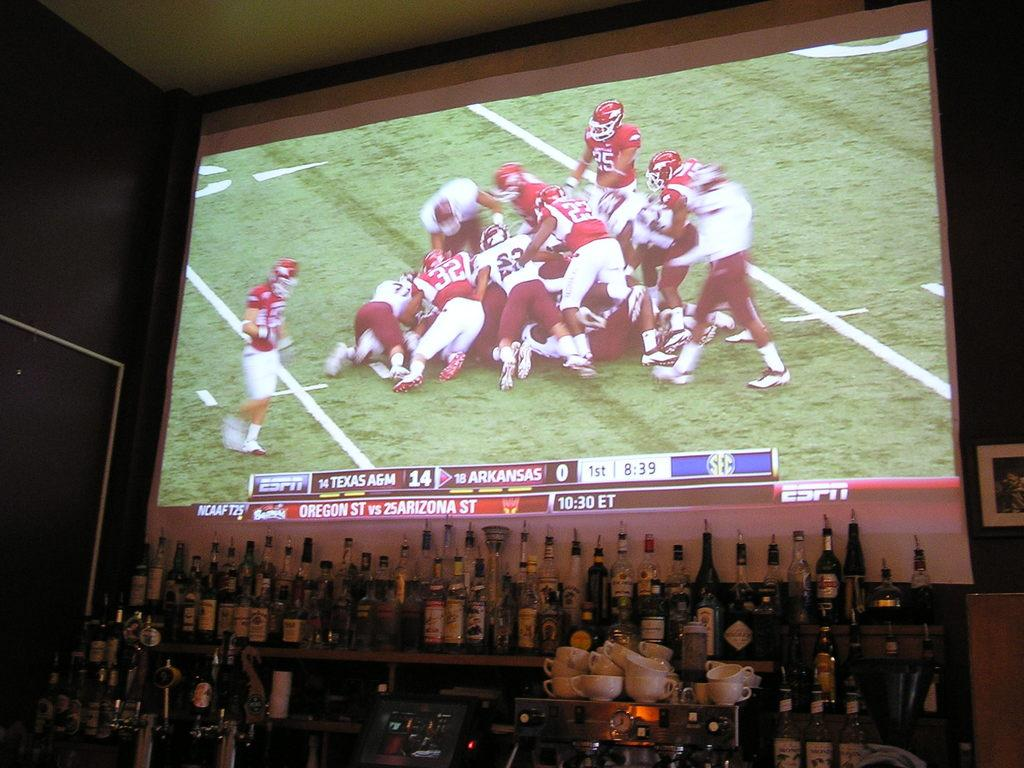<image>
Render a clear and concise summary of the photo. ESPN on the big screen behind the bar. 